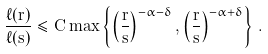<formula> <loc_0><loc_0><loc_500><loc_500>\frac { \ell ( r ) } { \ell ( s ) } \leq C \max \left \{ \left ( \frac { r } { s } \right ) ^ { - \alpha - \delta } , \left ( \frac { r } { s } \right ) ^ { - \alpha + \delta } \right \} \, .</formula> 